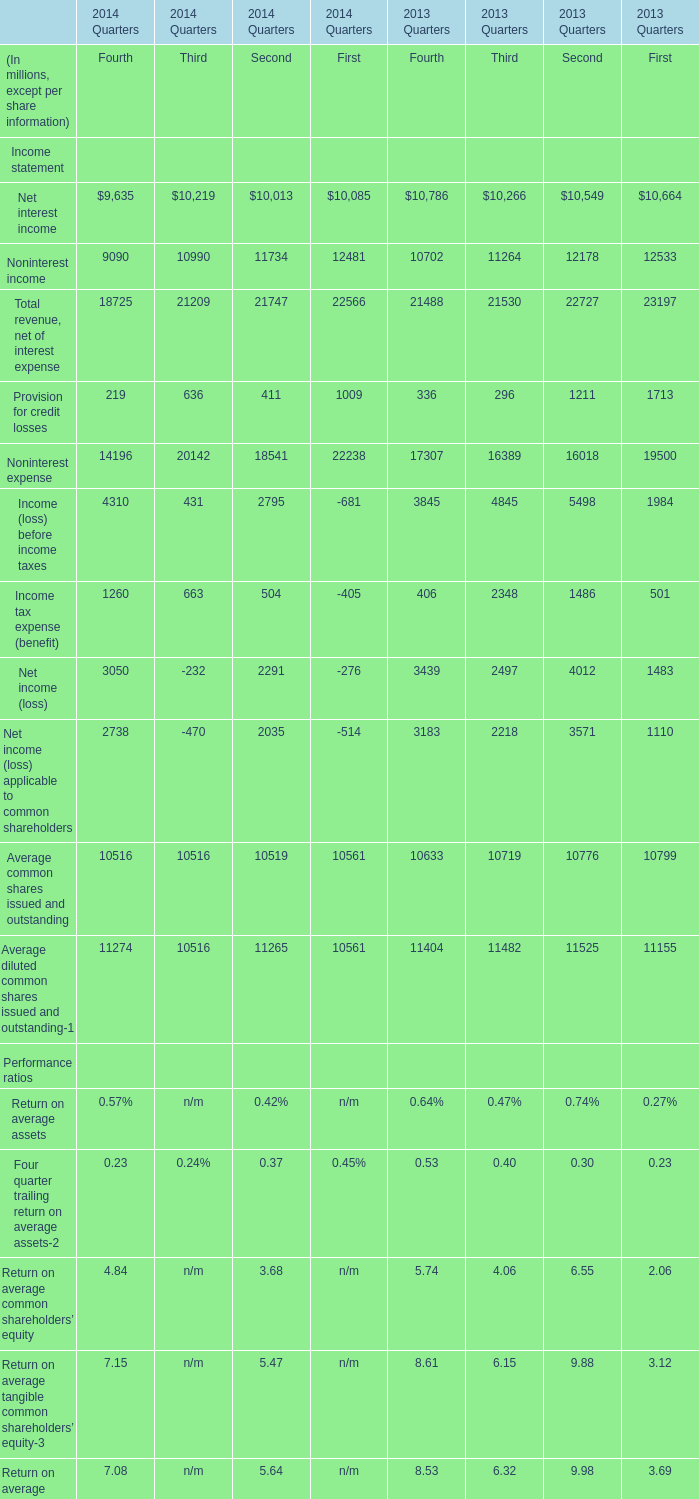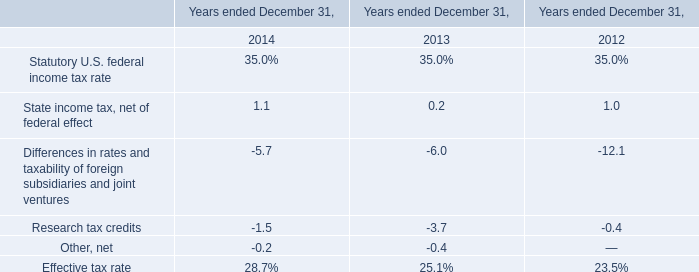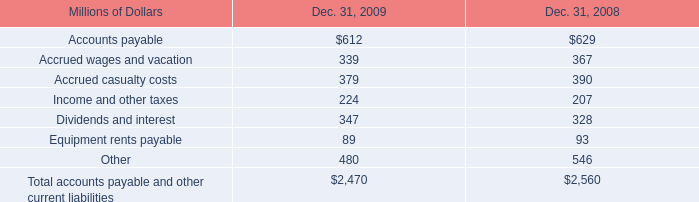How many elements are greater than 23000 in 2013? 
Answer: 1. 